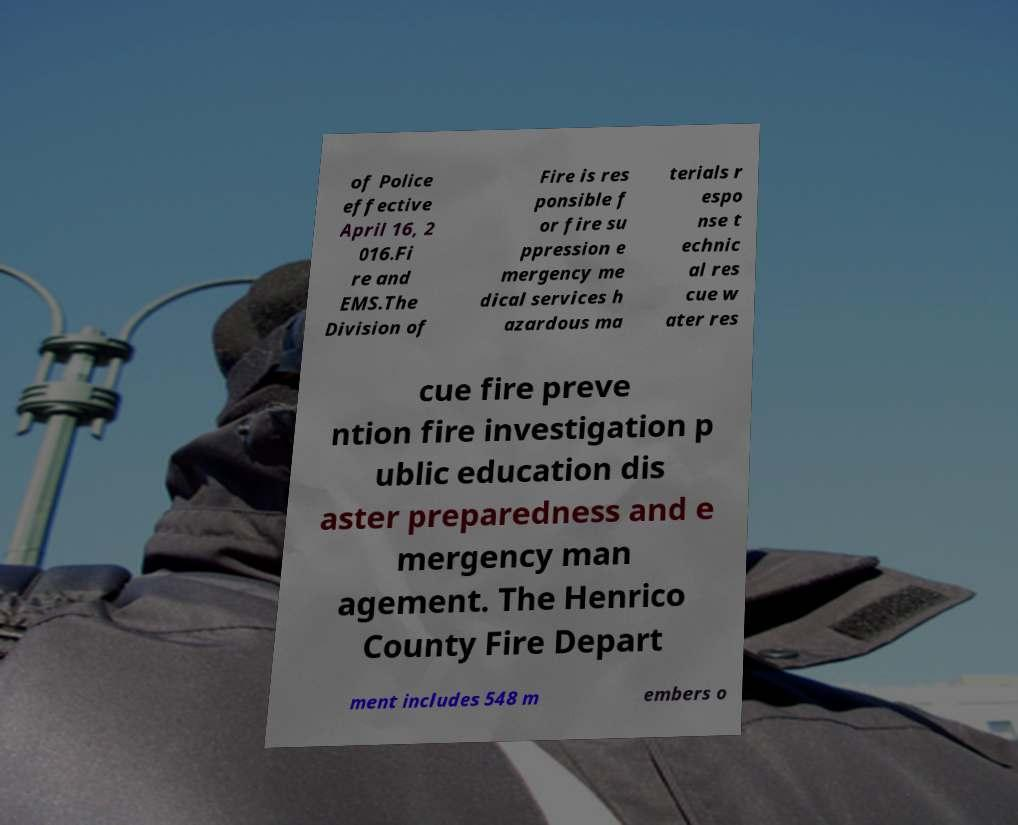There's text embedded in this image that I need extracted. Can you transcribe it verbatim? of Police effective April 16, 2 016.Fi re and EMS.The Division of Fire is res ponsible f or fire su ppression e mergency me dical services h azardous ma terials r espo nse t echnic al res cue w ater res cue fire preve ntion fire investigation p ublic education dis aster preparedness and e mergency man agement. The Henrico County Fire Depart ment includes 548 m embers o 